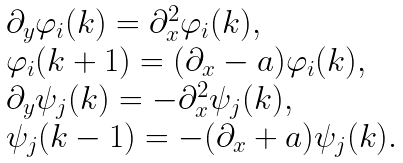<formula> <loc_0><loc_0><loc_500><loc_500>\begin{array} { l l } \partial _ { y } \varphi _ { i } ( k ) = \partial _ { x } ^ { 2 } \varphi _ { i } ( k ) , \\ \varphi _ { i } ( k + 1 ) = ( \partial _ { x } - a ) \varphi _ { i } ( k ) , \\ \partial _ { y } \psi _ { j } ( k ) = - \partial _ { x } ^ { 2 } \psi _ { j } ( k ) , \\ \psi _ { j } ( k - 1 ) = - ( \partial _ { x } + a ) \psi _ { j } ( k ) . \end{array}</formula> 